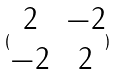Convert formula to latex. <formula><loc_0><loc_0><loc_500><loc_500>( \begin{matrix} 2 & - 2 \\ - 2 & 2 \end{matrix} )</formula> 